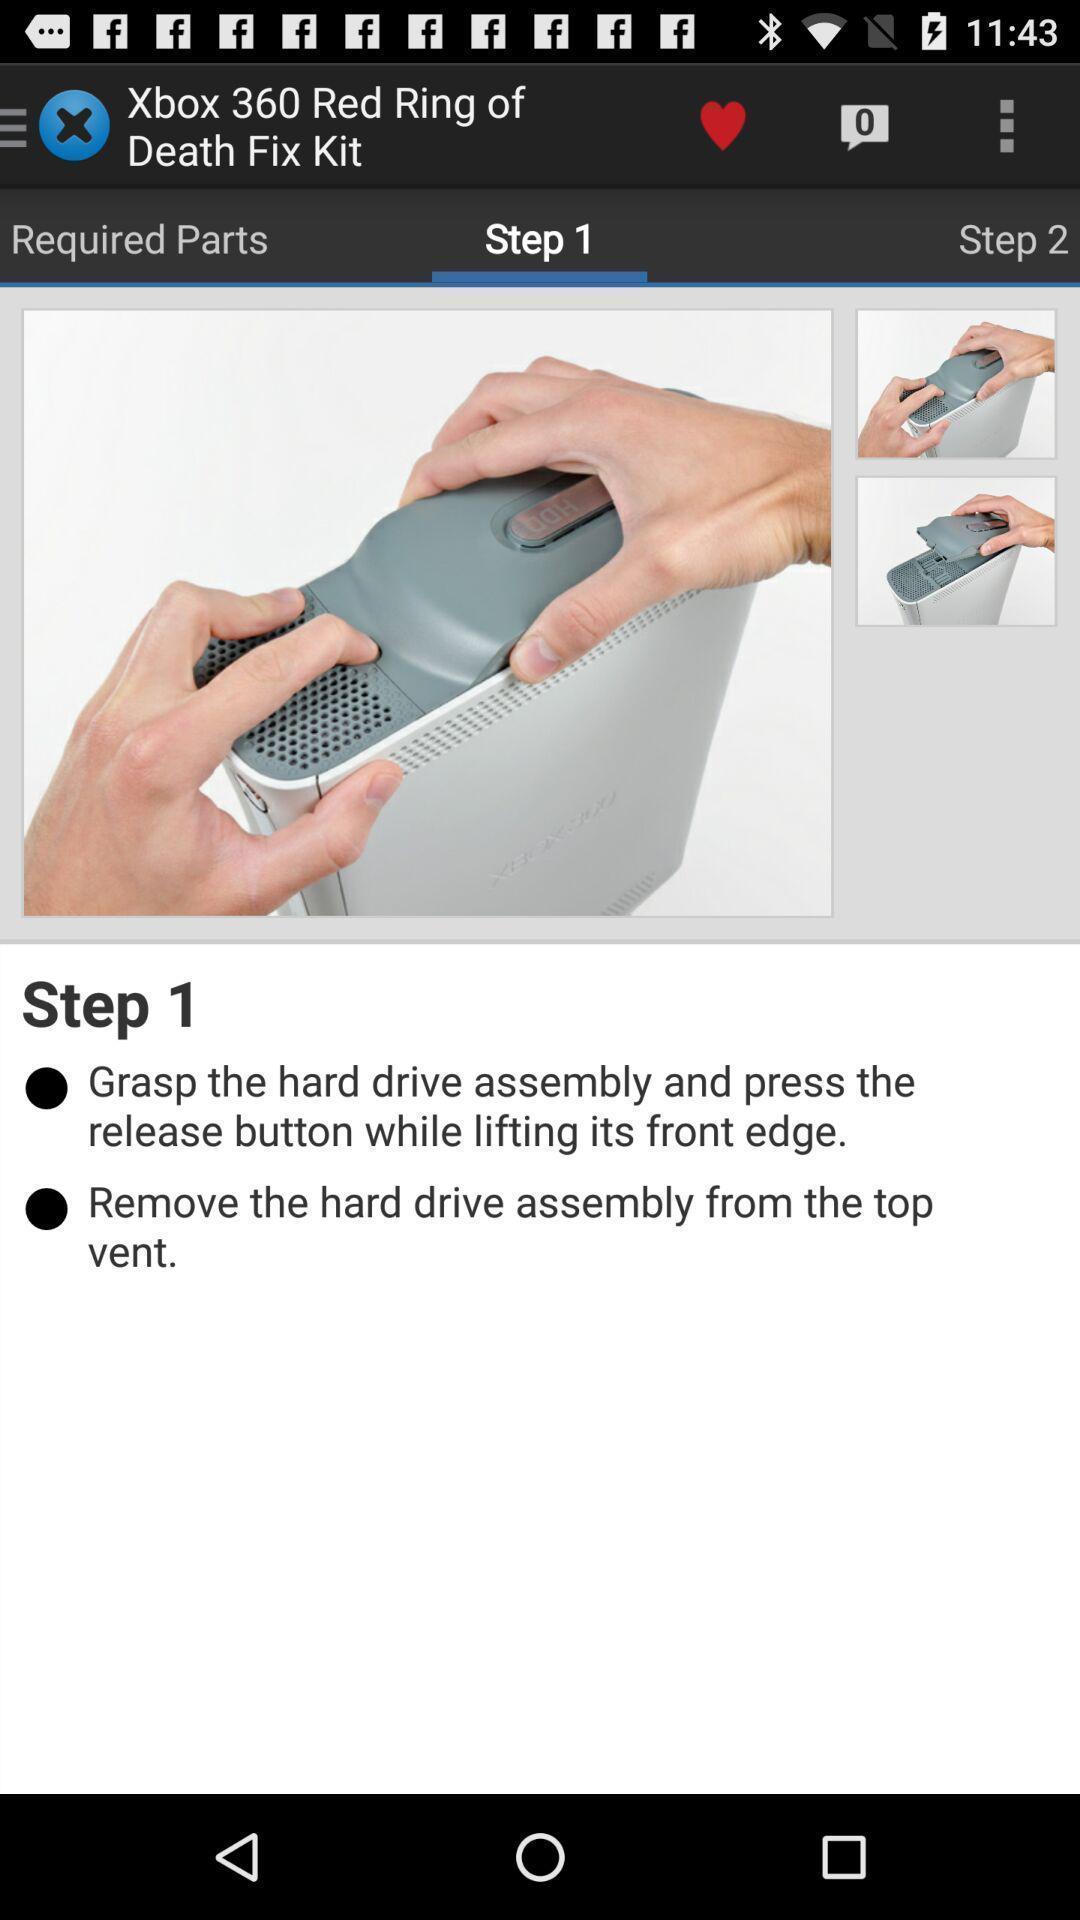Tell me what you see in this picture. Tutorial page of a game is displayed in the application. 